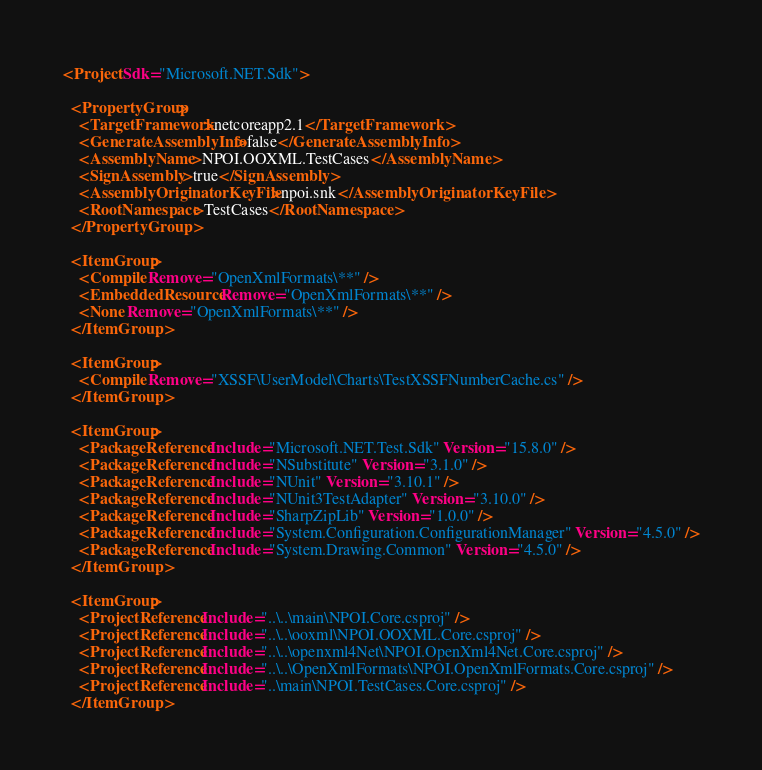<code> <loc_0><loc_0><loc_500><loc_500><_XML_><Project Sdk="Microsoft.NET.Sdk">

  <PropertyGroup>
    <TargetFramework>netcoreapp2.1</TargetFramework>
	<GenerateAssemblyInfo>false</GenerateAssemblyInfo>
	<AssemblyName>NPOI.OOXML.TestCases</AssemblyName>
	<SignAssembly>true</SignAssembly>
	<AssemblyOriginatorKeyFile>npoi.snk</AssemblyOriginatorKeyFile>
	<RootNamespace>TestCases</RootNamespace>
  </PropertyGroup>

  <ItemGroup>
    <Compile Remove="OpenXmlFormats\**" />
    <EmbeddedResource Remove="OpenXmlFormats\**" />
    <None Remove="OpenXmlFormats\**" />
  </ItemGroup>

  <ItemGroup>
    <Compile Remove="XSSF\UserModel\Charts\TestXSSFNumberCache.cs" />
  </ItemGroup>

  <ItemGroup>
    <PackageReference Include="Microsoft.NET.Test.Sdk" Version="15.8.0" />
    <PackageReference Include="NSubstitute" Version="3.1.0" />
    <PackageReference Include="NUnit" Version="3.10.1" />
    <PackageReference Include="NUnit3TestAdapter" Version="3.10.0" />
    <PackageReference Include="SharpZipLib" Version="1.0.0" />
    <PackageReference Include="System.Configuration.ConfigurationManager" Version="4.5.0" />
    <PackageReference Include="System.Drawing.Common" Version="4.5.0" />
  </ItemGroup>

  <ItemGroup>
    <ProjectReference Include="..\..\main\NPOI.Core.csproj" />
    <ProjectReference Include="..\..\ooxml\NPOI.OOXML.Core.csproj" />
    <ProjectReference Include="..\..\openxml4Net\NPOI.OpenXml4Net.Core.csproj" />
    <ProjectReference Include="..\..\OpenXmlFormats\NPOI.OpenXmlFormats.Core.csproj" />
    <ProjectReference Include="..\main\NPOI.TestCases.Core.csproj" />
  </ItemGroup>
</code> 